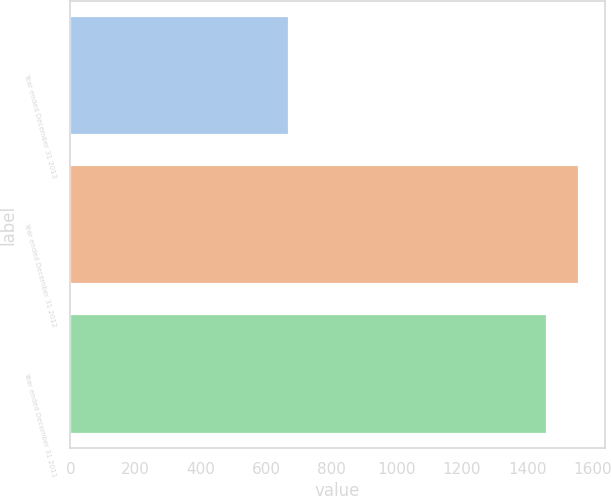Convert chart. <chart><loc_0><loc_0><loc_500><loc_500><bar_chart><fcel>Year ended December 31 2013<fcel>Year ended December 31 2012<fcel>Year ended December 31 2011<nl><fcel>669<fcel>1560<fcel>1459<nl></chart> 